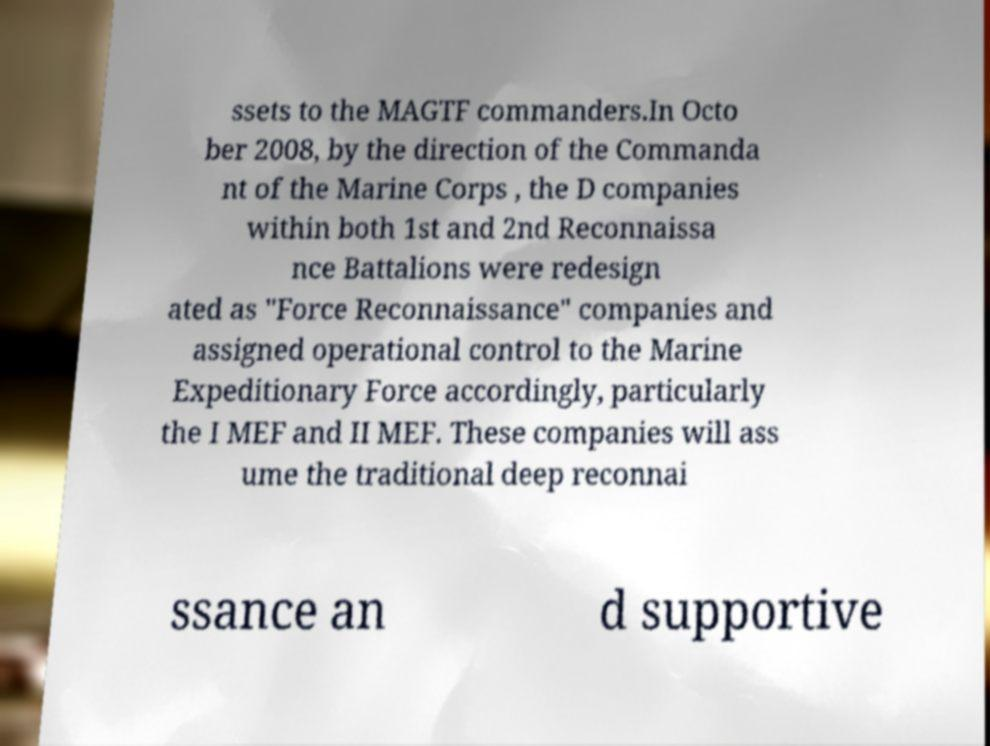Please identify and transcribe the text found in this image. ssets to the MAGTF commanders.In Octo ber 2008, by the direction of the Commanda nt of the Marine Corps , the D companies within both 1st and 2nd Reconnaissa nce Battalions were redesign ated as "Force Reconnaissance" companies and assigned operational control to the Marine Expeditionary Force accordingly, particularly the I MEF and II MEF. These companies will ass ume the traditional deep reconnai ssance an d supportive 